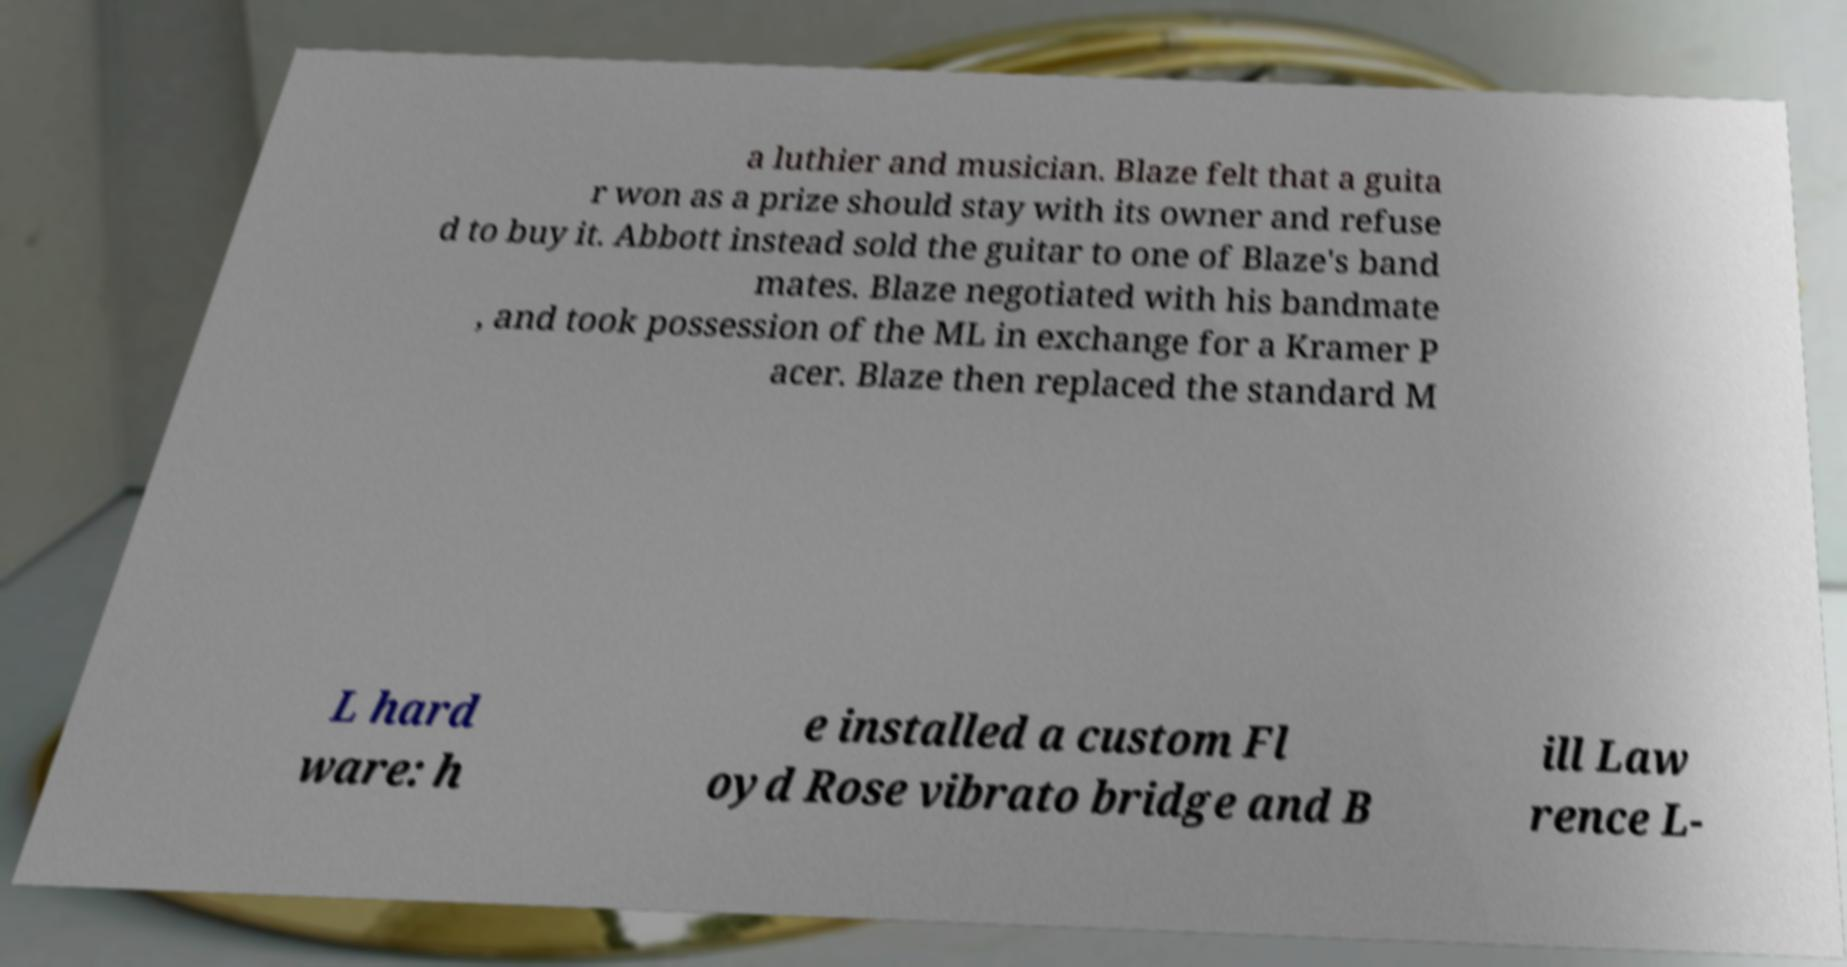Please identify and transcribe the text found in this image. a luthier and musician. Blaze felt that a guita r won as a prize should stay with its owner and refuse d to buy it. Abbott instead sold the guitar to one of Blaze's band mates. Blaze negotiated with his bandmate , and took possession of the ML in exchange for a Kramer P acer. Blaze then replaced the standard M L hard ware: h e installed a custom Fl oyd Rose vibrato bridge and B ill Law rence L- 